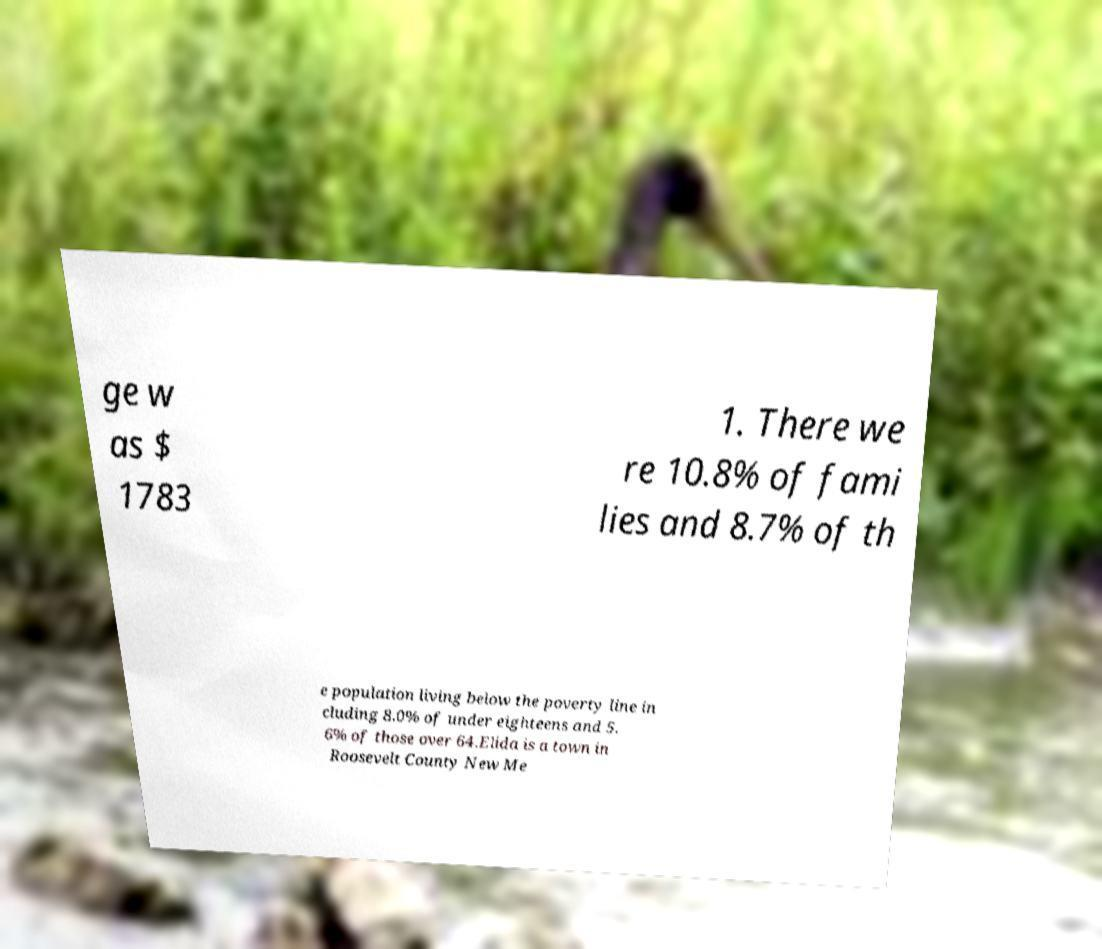What messages or text are displayed in this image? I need them in a readable, typed format. ge w as $ 1783 1. There we re 10.8% of fami lies and 8.7% of th e population living below the poverty line in cluding 8.0% of under eighteens and 5. 6% of those over 64.Elida is a town in Roosevelt County New Me 